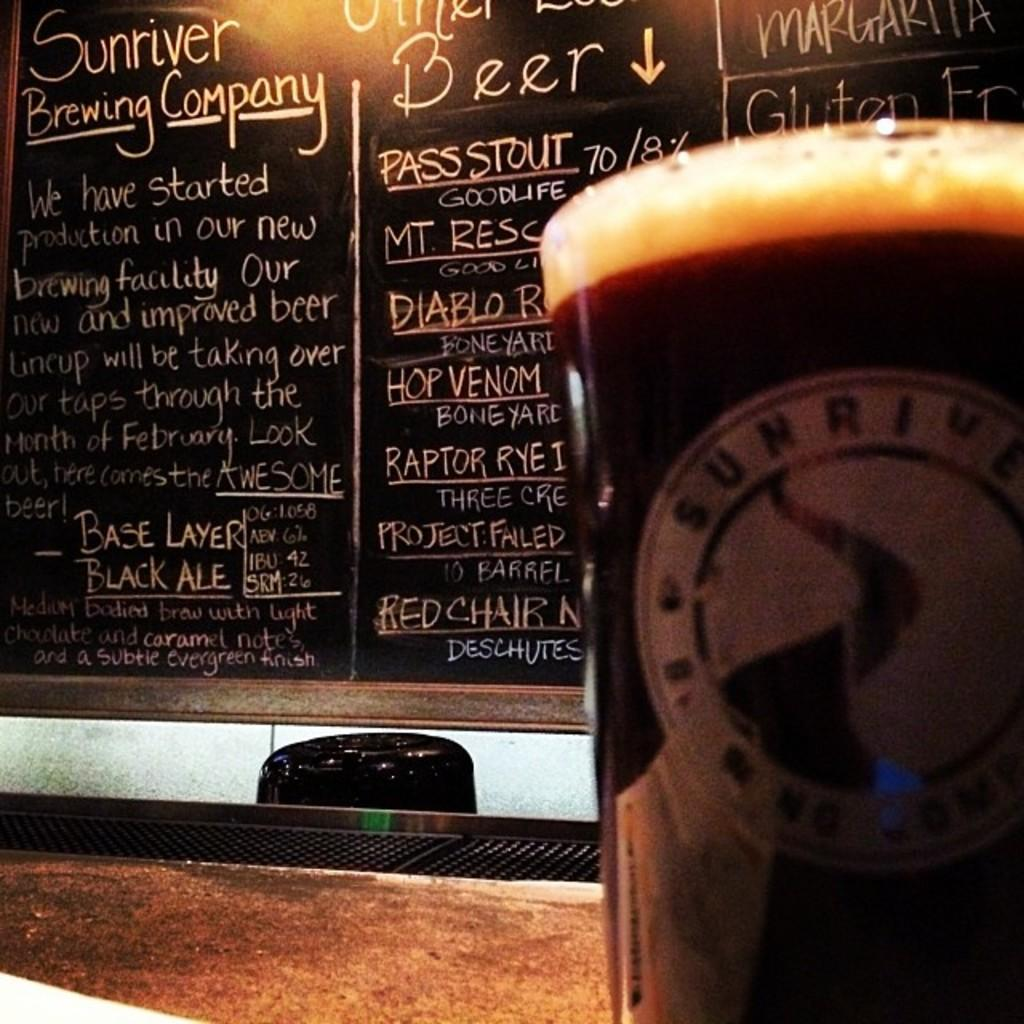What is located in the right corner of the image? There is a glass of drink in the right corner of the image. What can be seen in the background of the image? There is something written on a blackboard in the background of the image. Where is the silk drawer located in the image? There is no silk drawer present in the image. What type of class is being taught in the image? There is no class or indication of a class being taught in the image. 